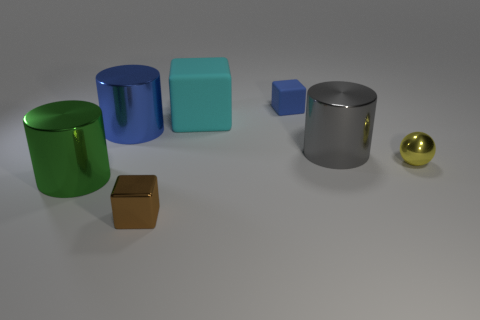What number of things are either metallic things that are behind the metal sphere or tiny rubber objects?
Ensure brevity in your answer.  3. Does the yellow object have the same shape as the small blue matte object?
Offer a very short reply. No. How many other things are there of the same size as the blue cylinder?
Offer a terse response. 3. The metal ball has what color?
Keep it short and to the point. Yellow. How many tiny things are either cyan matte cubes or blocks?
Make the answer very short. 2. Do the thing behind the cyan thing and the cylinder that is right of the brown thing have the same size?
Ensure brevity in your answer.  No. What size is the blue rubber object that is the same shape as the cyan thing?
Give a very brief answer. Small. Are there more large green cylinders behind the big cyan block than blue metallic things that are in front of the gray shiny cylinder?
Your answer should be compact. No. What is the cube that is behind the small shiny block and in front of the small blue object made of?
Provide a short and direct response. Rubber. What is the color of the other matte object that is the same shape as the cyan rubber thing?
Your answer should be very brief. Blue. 